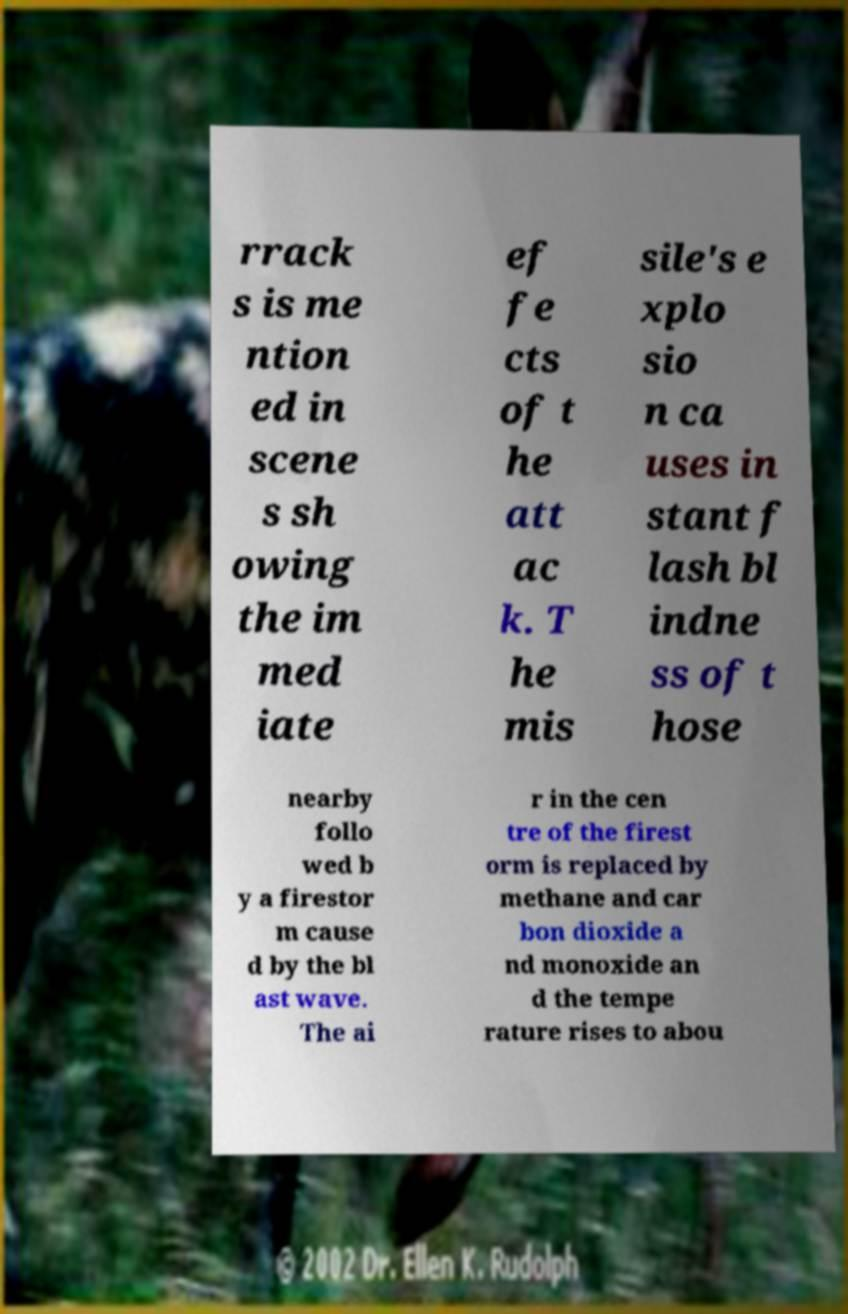For documentation purposes, I need the text within this image transcribed. Could you provide that? rrack s is me ntion ed in scene s sh owing the im med iate ef fe cts of t he att ac k. T he mis sile's e xplo sio n ca uses in stant f lash bl indne ss of t hose nearby follo wed b y a firestor m cause d by the bl ast wave. The ai r in the cen tre of the firest orm is replaced by methane and car bon dioxide a nd monoxide an d the tempe rature rises to abou 